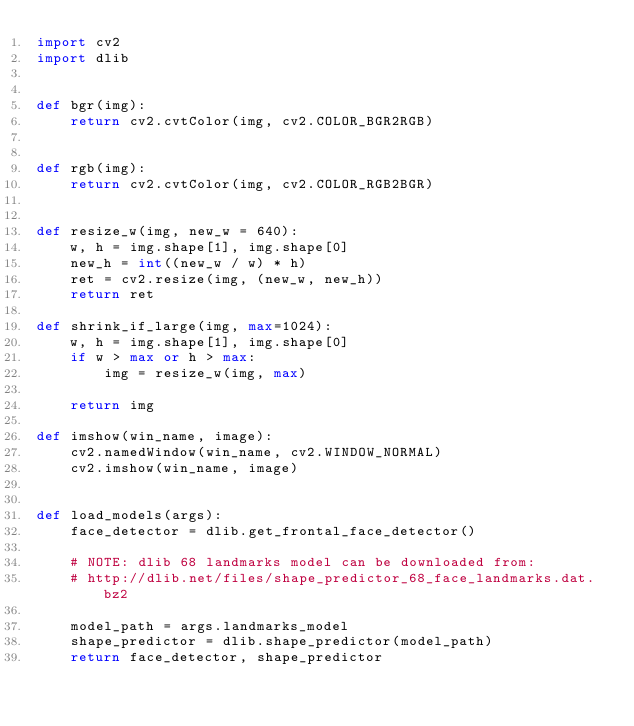Convert code to text. <code><loc_0><loc_0><loc_500><loc_500><_Python_>import cv2
import dlib


def bgr(img):
    return cv2.cvtColor(img, cv2.COLOR_BGR2RGB)


def rgb(img):
    return cv2.cvtColor(img, cv2.COLOR_RGB2BGR)


def resize_w(img, new_w = 640):
    w, h = img.shape[1], img.shape[0]
    new_h = int((new_w / w) * h)
    ret = cv2.resize(img, (new_w, new_h))
    return ret

def shrink_if_large(img, max=1024):
    w, h = img.shape[1], img.shape[0]
    if w > max or h > max:
        img = resize_w(img, max)

    return img

def imshow(win_name, image):
    cv2.namedWindow(win_name, cv2.WINDOW_NORMAL)
    cv2.imshow(win_name, image)


def load_models(args):
    face_detector = dlib.get_frontal_face_detector()

    # NOTE: dlib 68 landmarks model can be downloaded from:
    # http://dlib.net/files/shape_predictor_68_face_landmarks.dat.bz2

    model_path = args.landmarks_model
    shape_predictor = dlib.shape_predictor(model_path)
    return face_detector, shape_predictor
</code> 